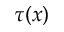<formula> <loc_0><loc_0><loc_500><loc_500>\tau ( x )</formula> 